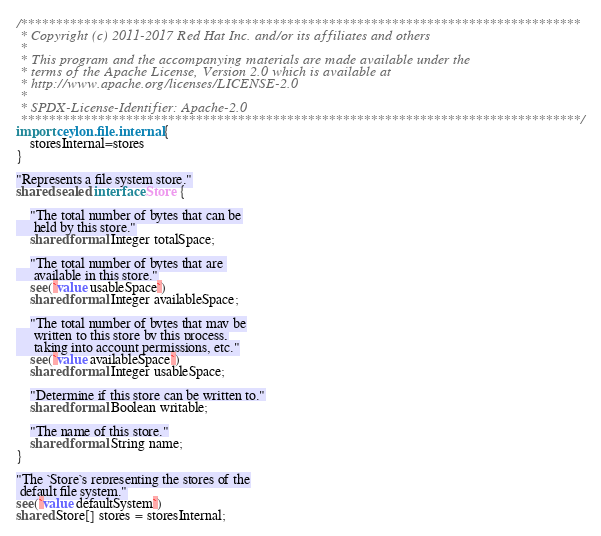Convert code to text. <code><loc_0><loc_0><loc_500><loc_500><_Ceylon_>/********************************************************************************
 * Copyright (c) 2011-2017 Red Hat Inc. and/or its affiliates and others
 *
 * This program and the accompanying materials are made available under the 
 * terms of the Apache License, Version 2.0 which is available at
 * http://www.apache.org/licenses/LICENSE-2.0
 *
 * SPDX-License-Identifier: Apache-2.0 
 ********************************************************************************/
import ceylon.file.internal {
    storesInternal=stores
}

"Represents a file system store."
shared sealed interface Store {
    
    "The total number of bytes that can be
     held by this store."
    shared formal Integer totalSpace;
    
    "The total number of bytes that are 
     available in this store."
    see(`value usableSpace`)
    shared formal Integer availableSpace;
    
    "The total number of bytes that may be
     written to this store by this process,
     taking into account permissions, etc."
    see(`value availableSpace`)
    shared formal Integer usableSpace;
    
    "Determine if this store can be written to."
    shared formal Boolean writable;
    
    "The name of this store."
    shared formal String name;
}

"The `Store`s representing the stores of the
 default file system."
see(`value defaultSystem`)
shared Store[] stores = storesInternal;</code> 